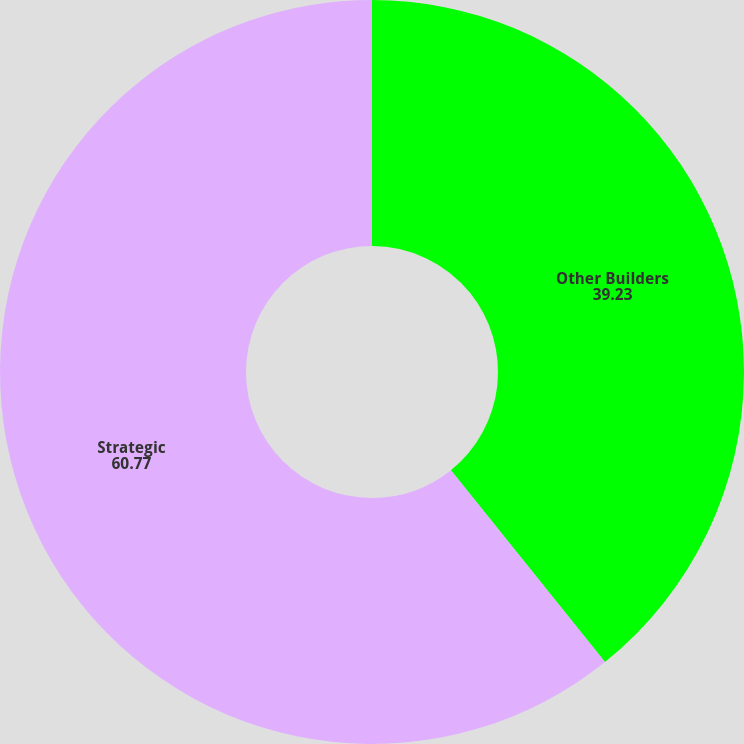Convert chart. <chart><loc_0><loc_0><loc_500><loc_500><pie_chart><fcel>Other Builders<fcel>Strategic<nl><fcel>39.23%<fcel>60.77%<nl></chart> 